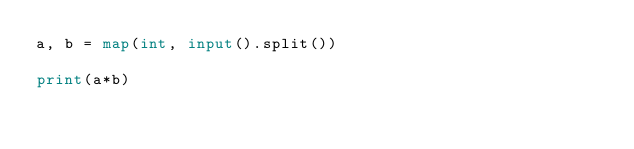Convert code to text. <code><loc_0><loc_0><loc_500><loc_500><_Python_>a, b = map(int, input().split())

print(a*b)</code> 